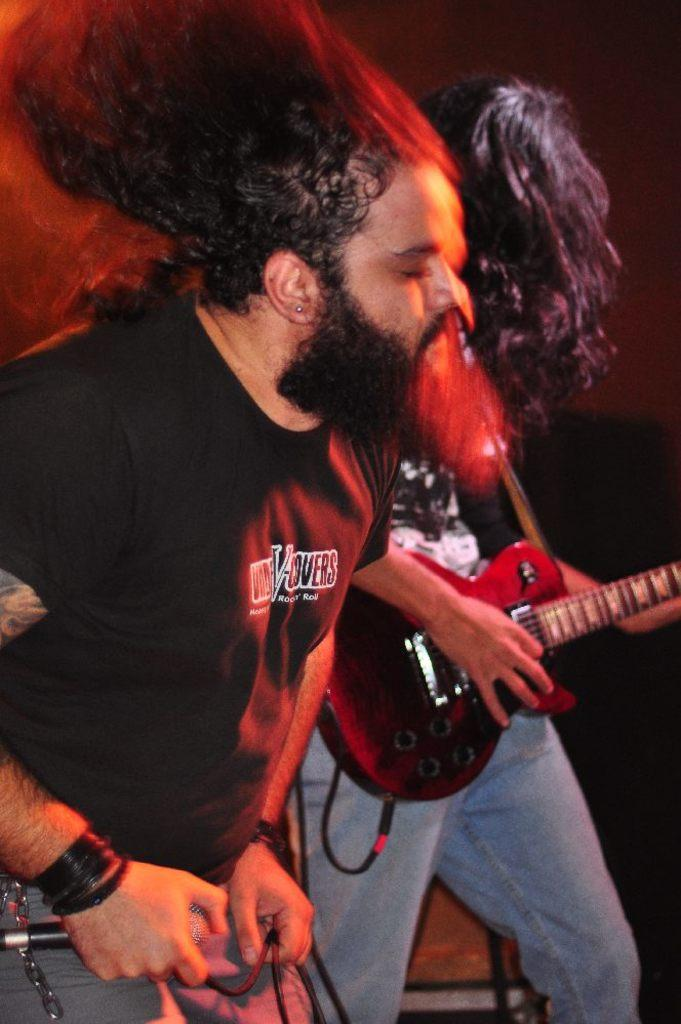How many people are in the image? There are two persons in the image. What is one person holding in the image? One person is holding a guitar. What is the other person holding in the image? The other person is holding a microphone. What type of shoes can be seen on the person holding the microphone? There is no mention of shoes in the image, so it cannot be determined what type of shoes the person is wearing. 